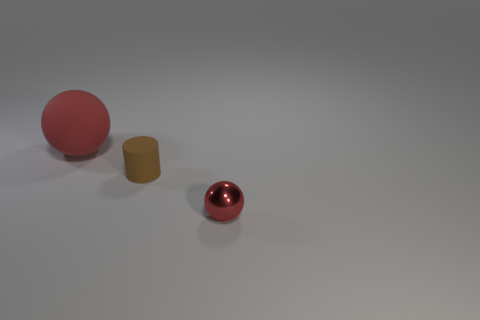Add 1 big cyan metal cylinders. How many objects exist? 4 Subtract all cylinders. How many objects are left? 2 Subtract 2 balls. How many balls are left? 0 Subtract all purple cylinders. How many gray spheres are left? 0 Subtract all big rubber balls. Subtract all tiny red things. How many objects are left? 1 Add 2 small red metal spheres. How many small red metal spheres are left? 3 Add 2 red shiny things. How many red shiny things exist? 3 Subtract 0 purple cylinders. How many objects are left? 3 Subtract all yellow cylinders. Subtract all gray balls. How many cylinders are left? 1 